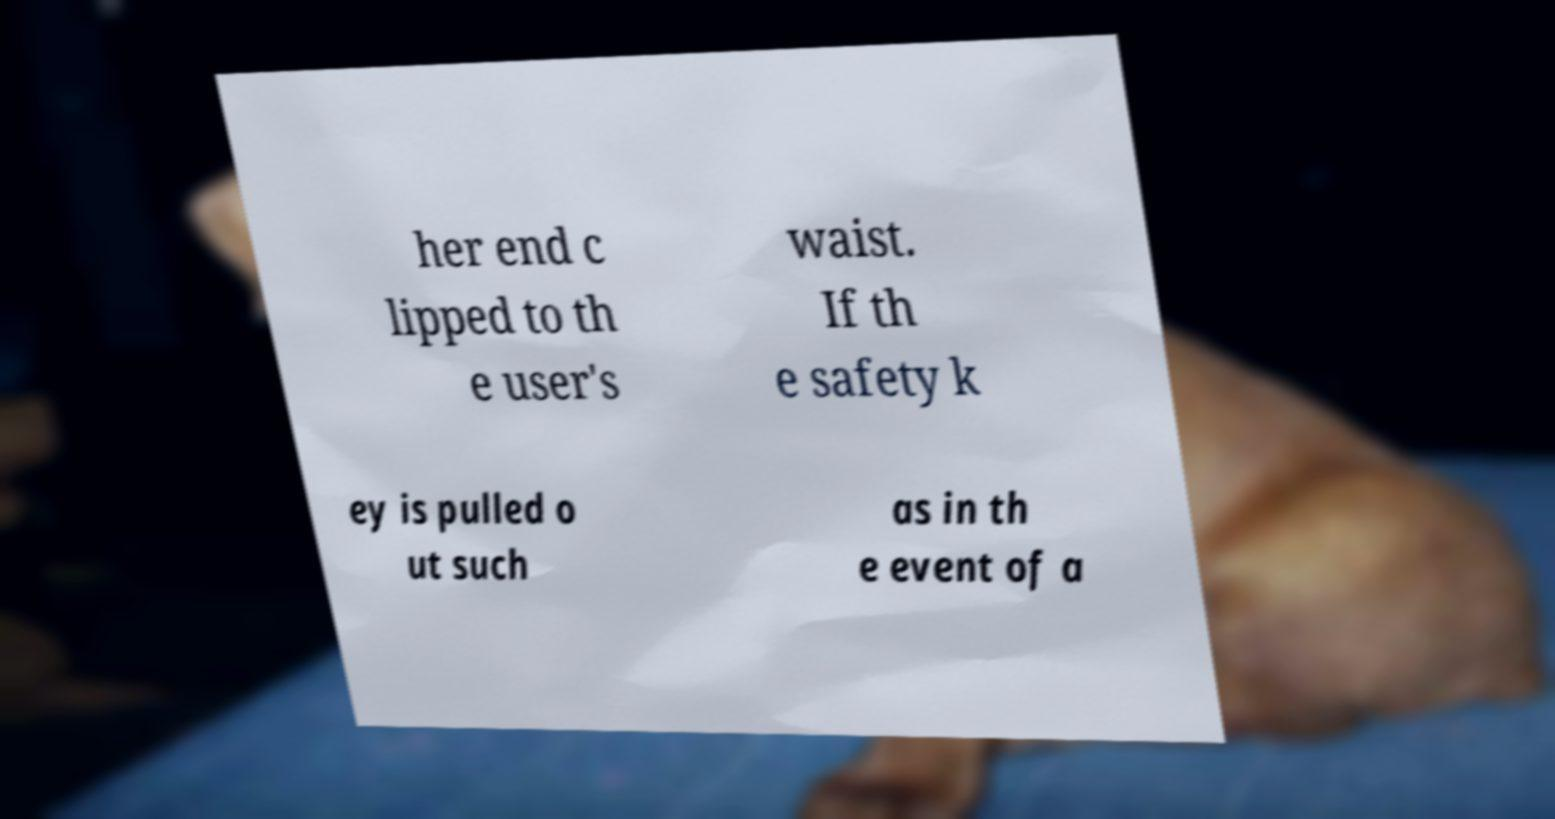Please identify and transcribe the text found in this image. her end c lipped to th e user's waist. If th e safety k ey is pulled o ut such as in th e event of a 